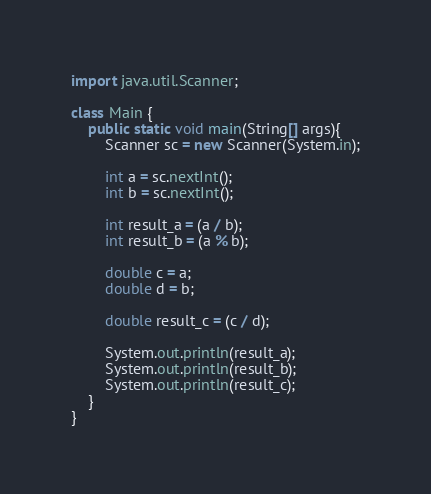Convert code to text. <code><loc_0><loc_0><loc_500><loc_500><_Java_>import java.util.Scanner;

class Main {
	public static void main(String[] args){
		Scanner sc = new Scanner(System.in);
		
		int a = sc.nextInt();
		int b = sc.nextInt();
		
		int result_a = (a / b);
		int result_b = (a % b);
		
		double c = a;
		double d = b;
		
		double result_c = (c / d);
		
		System.out.println(result_a);
		System.out.println(result_b);
		System.out.println(result_c);
	}
}</code> 